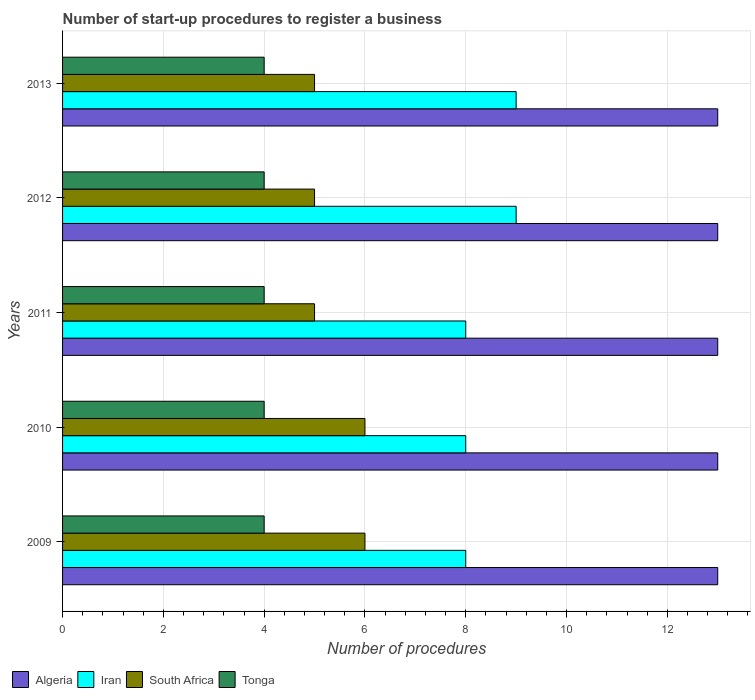How many different coloured bars are there?
Offer a very short reply. 4. Are the number of bars per tick equal to the number of legend labels?
Your answer should be very brief. Yes. How many bars are there on the 4th tick from the top?
Offer a very short reply. 4. How many bars are there on the 4th tick from the bottom?
Provide a short and direct response. 4. What is the label of the 4th group of bars from the top?
Offer a terse response. 2010. What is the number of procedures required to register a business in Algeria in 2010?
Provide a short and direct response. 13. Across all years, what is the maximum number of procedures required to register a business in South Africa?
Make the answer very short. 6. Across all years, what is the minimum number of procedures required to register a business in Tonga?
Offer a very short reply. 4. What is the total number of procedures required to register a business in Tonga in the graph?
Provide a short and direct response. 20. What is the difference between the number of procedures required to register a business in Tonga in 2009 and that in 2011?
Provide a short and direct response. 0. What is the difference between the number of procedures required to register a business in Tonga in 2009 and the number of procedures required to register a business in Iran in 2012?
Your answer should be compact. -5. In the year 2010, what is the difference between the number of procedures required to register a business in Tonga and number of procedures required to register a business in South Africa?
Make the answer very short. -2. Is the difference between the number of procedures required to register a business in Tonga in 2011 and 2013 greater than the difference between the number of procedures required to register a business in South Africa in 2011 and 2013?
Give a very brief answer. No. What is the difference between the highest and the lowest number of procedures required to register a business in Iran?
Keep it short and to the point. 1. Is it the case that in every year, the sum of the number of procedures required to register a business in South Africa and number of procedures required to register a business in Algeria is greater than the sum of number of procedures required to register a business in Tonga and number of procedures required to register a business in Iran?
Provide a short and direct response. Yes. What does the 1st bar from the top in 2011 represents?
Your answer should be very brief. Tonga. What does the 2nd bar from the bottom in 2013 represents?
Your answer should be very brief. Iran. How many bars are there?
Give a very brief answer. 20. How many years are there in the graph?
Your answer should be compact. 5. Does the graph contain any zero values?
Give a very brief answer. No. Does the graph contain grids?
Offer a very short reply. Yes. Where does the legend appear in the graph?
Give a very brief answer. Bottom left. How many legend labels are there?
Your answer should be very brief. 4. How are the legend labels stacked?
Provide a succinct answer. Horizontal. What is the title of the graph?
Your answer should be compact. Number of start-up procedures to register a business. What is the label or title of the X-axis?
Provide a short and direct response. Number of procedures. What is the label or title of the Y-axis?
Your answer should be very brief. Years. What is the Number of procedures of Algeria in 2009?
Provide a short and direct response. 13. What is the Number of procedures in Algeria in 2010?
Ensure brevity in your answer.  13. What is the Number of procedures of South Africa in 2010?
Offer a very short reply. 6. What is the Number of procedures in Iran in 2011?
Offer a very short reply. 8. What is the Number of procedures of South Africa in 2011?
Your answer should be very brief. 5. What is the Number of procedures in Tonga in 2011?
Ensure brevity in your answer.  4. What is the Number of procedures in Algeria in 2012?
Your response must be concise. 13. What is the Number of procedures in Iran in 2012?
Provide a succinct answer. 9. What is the Number of procedures in Algeria in 2013?
Provide a succinct answer. 13. What is the Number of procedures in South Africa in 2013?
Your response must be concise. 5. What is the Number of procedures of Tonga in 2013?
Offer a very short reply. 4. Across all years, what is the maximum Number of procedures of Algeria?
Keep it short and to the point. 13. Across all years, what is the maximum Number of procedures in Iran?
Your answer should be compact. 9. Across all years, what is the minimum Number of procedures of South Africa?
Offer a terse response. 5. Across all years, what is the minimum Number of procedures of Tonga?
Ensure brevity in your answer.  4. What is the total Number of procedures in Algeria in the graph?
Ensure brevity in your answer.  65. What is the total Number of procedures of South Africa in the graph?
Your answer should be very brief. 27. What is the difference between the Number of procedures in Algeria in 2009 and that in 2010?
Offer a very short reply. 0. What is the difference between the Number of procedures in South Africa in 2009 and that in 2010?
Your answer should be very brief. 0. What is the difference between the Number of procedures in Tonga in 2009 and that in 2010?
Your answer should be compact. 0. What is the difference between the Number of procedures of Algeria in 2009 and that in 2011?
Provide a succinct answer. 0. What is the difference between the Number of procedures in Iran in 2009 and that in 2011?
Your answer should be very brief. 0. What is the difference between the Number of procedures of Iran in 2009 and that in 2012?
Make the answer very short. -1. What is the difference between the Number of procedures of Tonga in 2009 and that in 2012?
Provide a succinct answer. 0. What is the difference between the Number of procedures of Iran in 2009 and that in 2013?
Provide a succinct answer. -1. What is the difference between the Number of procedures in South Africa in 2009 and that in 2013?
Your response must be concise. 1. What is the difference between the Number of procedures of South Africa in 2010 and that in 2012?
Keep it short and to the point. 1. What is the difference between the Number of procedures of Iran in 2010 and that in 2013?
Provide a succinct answer. -1. What is the difference between the Number of procedures of Tonga in 2010 and that in 2013?
Your response must be concise. 0. What is the difference between the Number of procedures of Iran in 2011 and that in 2012?
Your answer should be very brief. -1. What is the difference between the Number of procedures of South Africa in 2011 and that in 2012?
Offer a terse response. 0. What is the difference between the Number of procedures in Iran in 2011 and that in 2013?
Your answer should be compact. -1. What is the difference between the Number of procedures in Algeria in 2009 and the Number of procedures in Iran in 2010?
Provide a succinct answer. 5. What is the difference between the Number of procedures in Iran in 2009 and the Number of procedures in South Africa in 2010?
Keep it short and to the point. 2. What is the difference between the Number of procedures in Iran in 2009 and the Number of procedures in Tonga in 2011?
Ensure brevity in your answer.  4. What is the difference between the Number of procedures of Algeria in 2009 and the Number of procedures of Iran in 2012?
Make the answer very short. 4. What is the difference between the Number of procedures of Algeria in 2009 and the Number of procedures of South Africa in 2012?
Your answer should be compact. 8. What is the difference between the Number of procedures in Iran in 2009 and the Number of procedures in South Africa in 2012?
Provide a short and direct response. 3. What is the difference between the Number of procedures in South Africa in 2009 and the Number of procedures in Tonga in 2012?
Your answer should be very brief. 2. What is the difference between the Number of procedures in Iran in 2009 and the Number of procedures in South Africa in 2013?
Give a very brief answer. 3. What is the difference between the Number of procedures in Algeria in 2010 and the Number of procedures in Iran in 2011?
Your answer should be very brief. 5. What is the difference between the Number of procedures in Algeria in 2010 and the Number of procedures in Tonga in 2011?
Your answer should be compact. 9. What is the difference between the Number of procedures of Iran in 2010 and the Number of procedures of Tonga in 2011?
Your answer should be very brief. 4. What is the difference between the Number of procedures in South Africa in 2010 and the Number of procedures in Tonga in 2011?
Ensure brevity in your answer.  2. What is the difference between the Number of procedures in Algeria in 2010 and the Number of procedures in South Africa in 2012?
Offer a very short reply. 8. What is the difference between the Number of procedures of Iran in 2010 and the Number of procedures of South Africa in 2012?
Offer a terse response. 3. What is the difference between the Number of procedures of South Africa in 2010 and the Number of procedures of Tonga in 2012?
Provide a short and direct response. 2. What is the difference between the Number of procedures of Algeria in 2010 and the Number of procedures of South Africa in 2013?
Give a very brief answer. 8. What is the difference between the Number of procedures of Algeria in 2011 and the Number of procedures of Tonga in 2012?
Offer a very short reply. 9. What is the difference between the Number of procedures in South Africa in 2011 and the Number of procedures in Tonga in 2012?
Your answer should be compact. 1. What is the difference between the Number of procedures of Algeria in 2011 and the Number of procedures of South Africa in 2013?
Ensure brevity in your answer.  8. What is the difference between the Number of procedures in Algeria in 2012 and the Number of procedures in Iran in 2013?
Keep it short and to the point. 4. What is the difference between the Number of procedures in Algeria in 2012 and the Number of procedures in Tonga in 2013?
Your answer should be compact. 9. What is the difference between the Number of procedures in Iran in 2012 and the Number of procedures in Tonga in 2013?
Provide a short and direct response. 5. What is the difference between the Number of procedures of South Africa in 2012 and the Number of procedures of Tonga in 2013?
Your answer should be compact. 1. What is the average Number of procedures in Algeria per year?
Your answer should be compact. 13. What is the average Number of procedures of Iran per year?
Provide a short and direct response. 8.4. What is the average Number of procedures of South Africa per year?
Keep it short and to the point. 5.4. What is the average Number of procedures in Tonga per year?
Ensure brevity in your answer.  4. In the year 2009, what is the difference between the Number of procedures in Algeria and Number of procedures in Iran?
Your response must be concise. 5. In the year 2009, what is the difference between the Number of procedures of Algeria and Number of procedures of Tonga?
Make the answer very short. 9. In the year 2009, what is the difference between the Number of procedures of Iran and Number of procedures of Tonga?
Offer a very short reply. 4. In the year 2009, what is the difference between the Number of procedures of South Africa and Number of procedures of Tonga?
Offer a terse response. 2. In the year 2010, what is the difference between the Number of procedures in Iran and Number of procedures in South Africa?
Your answer should be compact. 2. In the year 2011, what is the difference between the Number of procedures of Algeria and Number of procedures of South Africa?
Ensure brevity in your answer.  8. In the year 2011, what is the difference between the Number of procedures of Algeria and Number of procedures of Tonga?
Provide a short and direct response. 9. In the year 2012, what is the difference between the Number of procedures in Algeria and Number of procedures in Tonga?
Your answer should be very brief. 9. In the year 2012, what is the difference between the Number of procedures of Iran and Number of procedures of Tonga?
Your response must be concise. 5. In the year 2012, what is the difference between the Number of procedures in South Africa and Number of procedures in Tonga?
Your answer should be compact. 1. In the year 2013, what is the difference between the Number of procedures of Iran and Number of procedures of South Africa?
Your answer should be compact. 4. In the year 2013, what is the difference between the Number of procedures of Iran and Number of procedures of Tonga?
Your answer should be compact. 5. In the year 2013, what is the difference between the Number of procedures in South Africa and Number of procedures in Tonga?
Make the answer very short. 1. What is the ratio of the Number of procedures of Algeria in 2009 to that in 2010?
Your answer should be compact. 1. What is the ratio of the Number of procedures of Iran in 2009 to that in 2010?
Provide a short and direct response. 1. What is the ratio of the Number of procedures of Tonga in 2009 to that in 2010?
Keep it short and to the point. 1. What is the ratio of the Number of procedures of Iran in 2009 to that in 2011?
Provide a short and direct response. 1. What is the ratio of the Number of procedures in Tonga in 2009 to that in 2011?
Provide a succinct answer. 1. What is the ratio of the Number of procedures of Algeria in 2009 to that in 2012?
Your answer should be compact. 1. What is the ratio of the Number of procedures in Algeria in 2009 to that in 2013?
Offer a terse response. 1. What is the ratio of the Number of procedures in Tonga in 2009 to that in 2013?
Keep it short and to the point. 1. What is the ratio of the Number of procedures in Algeria in 2010 to that in 2011?
Provide a short and direct response. 1. What is the ratio of the Number of procedures in South Africa in 2010 to that in 2011?
Give a very brief answer. 1.2. What is the ratio of the Number of procedures of Tonga in 2010 to that in 2011?
Give a very brief answer. 1. What is the ratio of the Number of procedures in Tonga in 2010 to that in 2012?
Ensure brevity in your answer.  1. What is the ratio of the Number of procedures of Iran in 2010 to that in 2013?
Give a very brief answer. 0.89. What is the ratio of the Number of procedures in Algeria in 2011 to that in 2012?
Provide a succinct answer. 1. What is the ratio of the Number of procedures in Iran in 2011 to that in 2012?
Make the answer very short. 0.89. What is the ratio of the Number of procedures of South Africa in 2011 to that in 2012?
Your answer should be very brief. 1. What is the ratio of the Number of procedures of Algeria in 2011 to that in 2013?
Provide a succinct answer. 1. What is the ratio of the Number of procedures in South Africa in 2011 to that in 2013?
Your answer should be compact. 1. What is the ratio of the Number of procedures of Tonga in 2011 to that in 2013?
Keep it short and to the point. 1. What is the ratio of the Number of procedures in Iran in 2012 to that in 2013?
Offer a terse response. 1. What is the ratio of the Number of procedures in South Africa in 2012 to that in 2013?
Offer a very short reply. 1. What is the difference between the highest and the second highest Number of procedures of Algeria?
Keep it short and to the point. 0. What is the difference between the highest and the second highest Number of procedures in Tonga?
Your response must be concise. 0. 